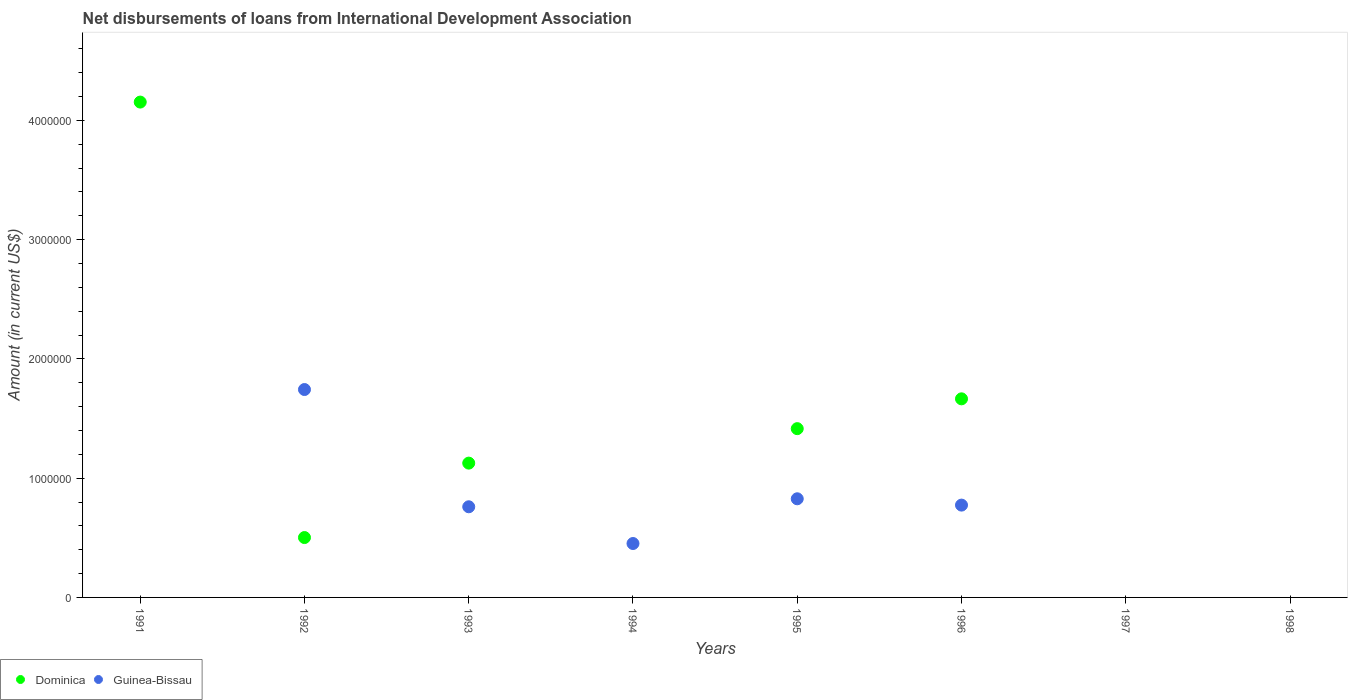How many different coloured dotlines are there?
Ensure brevity in your answer.  2. What is the amount of loans disbursed in Dominica in 1995?
Your answer should be compact. 1.42e+06. Across all years, what is the maximum amount of loans disbursed in Guinea-Bissau?
Make the answer very short. 1.74e+06. What is the total amount of loans disbursed in Dominica in the graph?
Your response must be concise. 8.86e+06. What is the difference between the amount of loans disbursed in Dominica in 1991 and that in 1993?
Provide a short and direct response. 3.03e+06. What is the difference between the amount of loans disbursed in Guinea-Bissau in 1993 and the amount of loans disbursed in Dominica in 1991?
Ensure brevity in your answer.  -3.39e+06. What is the average amount of loans disbursed in Guinea-Bissau per year?
Your answer should be compact. 5.70e+05. In the year 1995, what is the difference between the amount of loans disbursed in Dominica and amount of loans disbursed in Guinea-Bissau?
Your response must be concise. 5.88e+05. In how many years, is the amount of loans disbursed in Guinea-Bissau greater than 3000000 US$?
Your response must be concise. 0. What is the ratio of the amount of loans disbursed in Dominica in 1993 to that in 1995?
Give a very brief answer. 0.8. What is the difference between the highest and the second highest amount of loans disbursed in Dominica?
Provide a succinct answer. 2.49e+06. What is the difference between the highest and the lowest amount of loans disbursed in Dominica?
Give a very brief answer. 4.15e+06. Does the amount of loans disbursed in Dominica monotonically increase over the years?
Offer a very short reply. No. Is the amount of loans disbursed in Guinea-Bissau strictly greater than the amount of loans disbursed in Dominica over the years?
Give a very brief answer. No. Is the amount of loans disbursed in Dominica strictly less than the amount of loans disbursed in Guinea-Bissau over the years?
Keep it short and to the point. No. How many years are there in the graph?
Provide a succinct answer. 8. What is the difference between two consecutive major ticks on the Y-axis?
Your response must be concise. 1.00e+06. Does the graph contain any zero values?
Ensure brevity in your answer.  Yes. What is the title of the graph?
Your answer should be very brief. Net disbursements of loans from International Development Association. What is the label or title of the Y-axis?
Offer a terse response. Amount (in current US$). What is the Amount (in current US$) in Dominica in 1991?
Offer a very short reply. 4.15e+06. What is the Amount (in current US$) in Dominica in 1992?
Offer a very short reply. 5.02e+05. What is the Amount (in current US$) of Guinea-Bissau in 1992?
Make the answer very short. 1.74e+06. What is the Amount (in current US$) in Dominica in 1993?
Provide a short and direct response. 1.13e+06. What is the Amount (in current US$) of Guinea-Bissau in 1993?
Ensure brevity in your answer.  7.60e+05. What is the Amount (in current US$) in Dominica in 1994?
Offer a terse response. 0. What is the Amount (in current US$) of Guinea-Bissau in 1994?
Offer a terse response. 4.52e+05. What is the Amount (in current US$) in Dominica in 1995?
Make the answer very short. 1.42e+06. What is the Amount (in current US$) in Guinea-Bissau in 1995?
Offer a terse response. 8.27e+05. What is the Amount (in current US$) in Dominica in 1996?
Keep it short and to the point. 1.66e+06. What is the Amount (in current US$) of Guinea-Bissau in 1996?
Offer a very short reply. 7.74e+05. What is the Amount (in current US$) in Dominica in 1997?
Give a very brief answer. 0. What is the Amount (in current US$) of Guinea-Bissau in 1998?
Make the answer very short. 0. Across all years, what is the maximum Amount (in current US$) in Dominica?
Your answer should be very brief. 4.15e+06. Across all years, what is the maximum Amount (in current US$) of Guinea-Bissau?
Keep it short and to the point. 1.74e+06. What is the total Amount (in current US$) of Dominica in the graph?
Offer a very short reply. 8.86e+06. What is the total Amount (in current US$) in Guinea-Bissau in the graph?
Give a very brief answer. 4.56e+06. What is the difference between the Amount (in current US$) of Dominica in 1991 and that in 1992?
Give a very brief answer. 3.65e+06. What is the difference between the Amount (in current US$) of Dominica in 1991 and that in 1993?
Your answer should be very brief. 3.03e+06. What is the difference between the Amount (in current US$) of Dominica in 1991 and that in 1995?
Give a very brief answer. 2.74e+06. What is the difference between the Amount (in current US$) of Dominica in 1991 and that in 1996?
Your answer should be very brief. 2.49e+06. What is the difference between the Amount (in current US$) in Dominica in 1992 and that in 1993?
Keep it short and to the point. -6.24e+05. What is the difference between the Amount (in current US$) of Guinea-Bissau in 1992 and that in 1993?
Keep it short and to the point. 9.83e+05. What is the difference between the Amount (in current US$) in Guinea-Bissau in 1992 and that in 1994?
Ensure brevity in your answer.  1.29e+06. What is the difference between the Amount (in current US$) in Dominica in 1992 and that in 1995?
Give a very brief answer. -9.13e+05. What is the difference between the Amount (in current US$) in Guinea-Bissau in 1992 and that in 1995?
Your answer should be compact. 9.16e+05. What is the difference between the Amount (in current US$) of Dominica in 1992 and that in 1996?
Keep it short and to the point. -1.16e+06. What is the difference between the Amount (in current US$) in Guinea-Bissau in 1992 and that in 1996?
Your response must be concise. 9.69e+05. What is the difference between the Amount (in current US$) of Guinea-Bissau in 1993 and that in 1994?
Offer a terse response. 3.08e+05. What is the difference between the Amount (in current US$) in Dominica in 1993 and that in 1995?
Ensure brevity in your answer.  -2.89e+05. What is the difference between the Amount (in current US$) of Guinea-Bissau in 1993 and that in 1995?
Offer a terse response. -6.70e+04. What is the difference between the Amount (in current US$) of Dominica in 1993 and that in 1996?
Offer a terse response. -5.39e+05. What is the difference between the Amount (in current US$) of Guinea-Bissau in 1993 and that in 1996?
Offer a terse response. -1.40e+04. What is the difference between the Amount (in current US$) in Guinea-Bissau in 1994 and that in 1995?
Keep it short and to the point. -3.75e+05. What is the difference between the Amount (in current US$) of Guinea-Bissau in 1994 and that in 1996?
Provide a short and direct response. -3.22e+05. What is the difference between the Amount (in current US$) in Guinea-Bissau in 1995 and that in 1996?
Make the answer very short. 5.30e+04. What is the difference between the Amount (in current US$) in Dominica in 1991 and the Amount (in current US$) in Guinea-Bissau in 1992?
Offer a very short reply. 2.41e+06. What is the difference between the Amount (in current US$) in Dominica in 1991 and the Amount (in current US$) in Guinea-Bissau in 1993?
Provide a succinct answer. 3.39e+06. What is the difference between the Amount (in current US$) in Dominica in 1991 and the Amount (in current US$) in Guinea-Bissau in 1994?
Your answer should be compact. 3.70e+06. What is the difference between the Amount (in current US$) of Dominica in 1991 and the Amount (in current US$) of Guinea-Bissau in 1995?
Your answer should be very brief. 3.33e+06. What is the difference between the Amount (in current US$) in Dominica in 1991 and the Amount (in current US$) in Guinea-Bissau in 1996?
Provide a succinct answer. 3.38e+06. What is the difference between the Amount (in current US$) in Dominica in 1992 and the Amount (in current US$) in Guinea-Bissau in 1993?
Your response must be concise. -2.58e+05. What is the difference between the Amount (in current US$) in Dominica in 1992 and the Amount (in current US$) in Guinea-Bissau in 1994?
Keep it short and to the point. 5.00e+04. What is the difference between the Amount (in current US$) in Dominica in 1992 and the Amount (in current US$) in Guinea-Bissau in 1995?
Provide a succinct answer. -3.25e+05. What is the difference between the Amount (in current US$) in Dominica in 1992 and the Amount (in current US$) in Guinea-Bissau in 1996?
Keep it short and to the point. -2.72e+05. What is the difference between the Amount (in current US$) of Dominica in 1993 and the Amount (in current US$) of Guinea-Bissau in 1994?
Keep it short and to the point. 6.74e+05. What is the difference between the Amount (in current US$) of Dominica in 1993 and the Amount (in current US$) of Guinea-Bissau in 1995?
Keep it short and to the point. 2.99e+05. What is the difference between the Amount (in current US$) in Dominica in 1993 and the Amount (in current US$) in Guinea-Bissau in 1996?
Provide a succinct answer. 3.52e+05. What is the difference between the Amount (in current US$) of Dominica in 1995 and the Amount (in current US$) of Guinea-Bissau in 1996?
Offer a terse response. 6.41e+05. What is the average Amount (in current US$) in Dominica per year?
Make the answer very short. 1.11e+06. What is the average Amount (in current US$) in Guinea-Bissau per year?
Provide a succinct answer. 5.70e+05. In the year 1992, what is the difference between the Amount (in current US$) of Dominica and Amount (in current US$) of Guinea-Bissau?
Your answer should be very brief. -1.24e+06. In the year 1993, what is the difference between the Amount (in current US$) in Dominica and Amount (in current US$) in Guinea-Bissau?
Your answer should be very brief. 3.66e+05. In the year 1995, what is the difference between the Amount (in current US$) in Dominica and Amount (in current US$) in Guinea-Bissau?
Offer a terse response. 5.88e+05. In the year 1996, what is the difference between the Amount (in current US$) in Dominica and Amount (in current US$) in Guinea-Bissau?
Make the answer very short. 8.91e+05. What is the ratio of the Amount (in current US$) in Dominica in 1991 to that in 1992?
Your answer should be compact. 8.27. What is the ratio of the Amount (in current US$) of Dominica in 1991 to that in 1993?
Your response must be concise. 3.69. What is the ratio of the Amount (in current US$) in Dominica in 1991 to that in 1995?
Ensure brevity in your answer.  2.94. What is the ratio of the Amount (in current US$) of Dominica in 1991 to that in 1996?
Your response must be concise. 2.49. What is the ratio of the Amount (in current US$) of Dominica in 1992 to that in 1993?
Ensure brevity in your answer.  0.45. What is the ratio of the Amount (in current US$) of Guinea-Bissau in 1992 to that in 1993?
Provide a short and direct response. 2.29. What is the ratio of the Amount (in current US$) in Guinea-Bissau in 1992 to that in 1994?
Your answer should be compact. 3.86. What is the ratio of the Amount (in current US$) of Dominica in 1992 to that in 1995?
Make the answer very short. 0.35. What is the ratio of the Amount (in current US$) in Guinea-Bissau in 1992 to that in 1995?
Offer a very short reply. 2.11. What is the ratio of the Amount (in current US$) of Dominica in 1992 to that in 1996?
Provide a short and direct response. 0.3. What is the ratio of the Amount (in current US$) in Guinea-Bissau in 1992 to that in 1996?
Your answer should be very brief. 2.25. What is the ratio of the Amount (in current US$) in Guinea-Bissau in 1993 to that in 1994?
Give a very brief answer. 1.68. What is the ratio of the Amount (in current US$) of Dominica in 1993 to that in 1995?
Keep it short and to the point. 0.8. What is the ratio of the Amount (in current US$) of Guinea-Bissau in 1993 to that in 1995?
Keep it short and to the point. 0.92. What is the ratio of the Amount (in current US$) of Dominica in 1993 to that in 1996?
Provide a succinct answer. 0.68. What is the ratio of the Amount (in current US$) of Guinea-Bissau in 1993 to that in 1996?
Your answer should be very brief. 0.98. What is the ratio of the Amount (in current US$) in Guinea-Bissau in 1994 to that in 1995?
Offer a terse response. 0.55. What is the ratio of the Amount (in current US$) of Guinea-Bissau in 1994 to that in 1996?
Offer a very short reply. 0.58. What is the ratio of the Amount (in current US$) of Dominica in 1995 to that in 1996?
Your answer should be compact. 0.85. What is the ratio of the Amount (in current US$) in Guinea-Bissau in 1995 to that in 1996?
Provide a succinct answer. 1.07. What is the difference between the highest and the second highest Amount (in current US$) in Dominica?
Give a very brief answer. 2.49e+06. What is the difference between the highest and the second highest Amount (in current US$) of Guinea-Bissau?
Make the answer very short. 9.16e+05. What is the difference between the highest and the lowest Amount (in current US$) of Dominica?
Your answer should be very brief. 4.15e+06. What is the difference between the highest and the lowest Amount (in current US$) of Guinea-Bissau?
Offer a very short reply. 1.74e+06. 